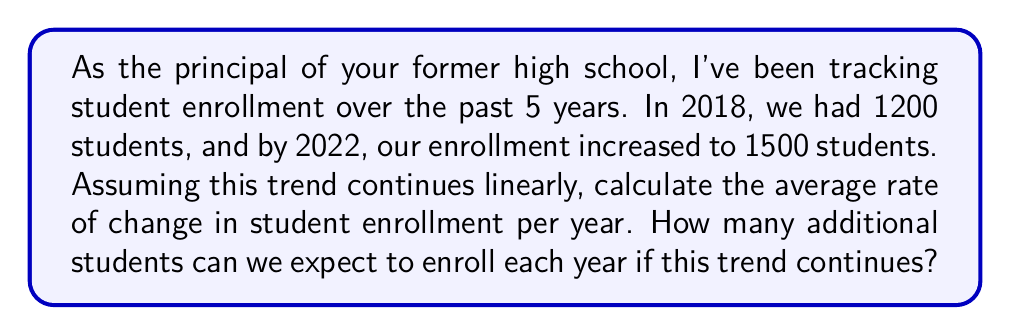Provide a solution to this math problem. Let's approach this step-by-step using a linear function:

1) We can represent the enrollment (y) as a function of time (x) using the linear function:
   $y = mx + b$
   where m is the rate of change (slope) and b is the initial enrollment.

2) We have two points:
   (2018, 1200) and (2022, 1500)

3) To find the rate of change (m), we use the slope formula:
   $m = \frac{y_2 - y_1}{x_2 - x_1} = \frac{1500 - 1200}{2022 - 2018} = \frac{300}{4} = 75$

4) This means the enrollment is increasing by 75 students per year on average.

5) We can verify this by plugging in our points to the linear function:
   $y = 75x + b$
   $1200 = 75(2018) + b$
   $b = 1200 - 75(2018) = -150,150$

6) Our linear function is therefore:
   $y = 75x - 150,150$

7) We can use this to predict future enrollment, but the key information is the rate of change, which is 75 students per year.
Answer: 75 students per year 